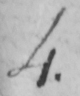Please provide the text content of this handwritten line. 4 . 